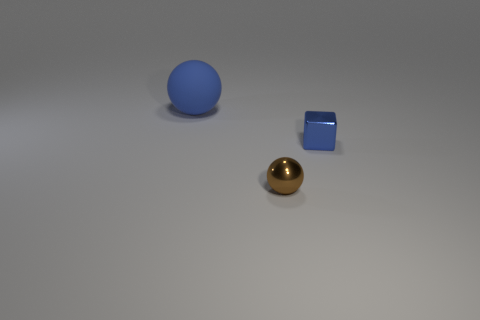Subtract all blue balls. How many balls are left? 1 Add 3 brown things. How many objects exist? 6 Subtract all spheres. How many objects are left? 1 Add 3 big blue shiny cylinders. How many big blue shiny cylinders exist? 3 Subtract 0 yellow balls. How many objects are left? 3 Subtract all blue balls. Subtract all yellow cubes. How many balls are left? 1 Subtract all small blue things. Subtract all big green matte blocks. How many objects are left? 2 Add 2 blue shiny cubes. How many blue shiny cubes are left? 3 